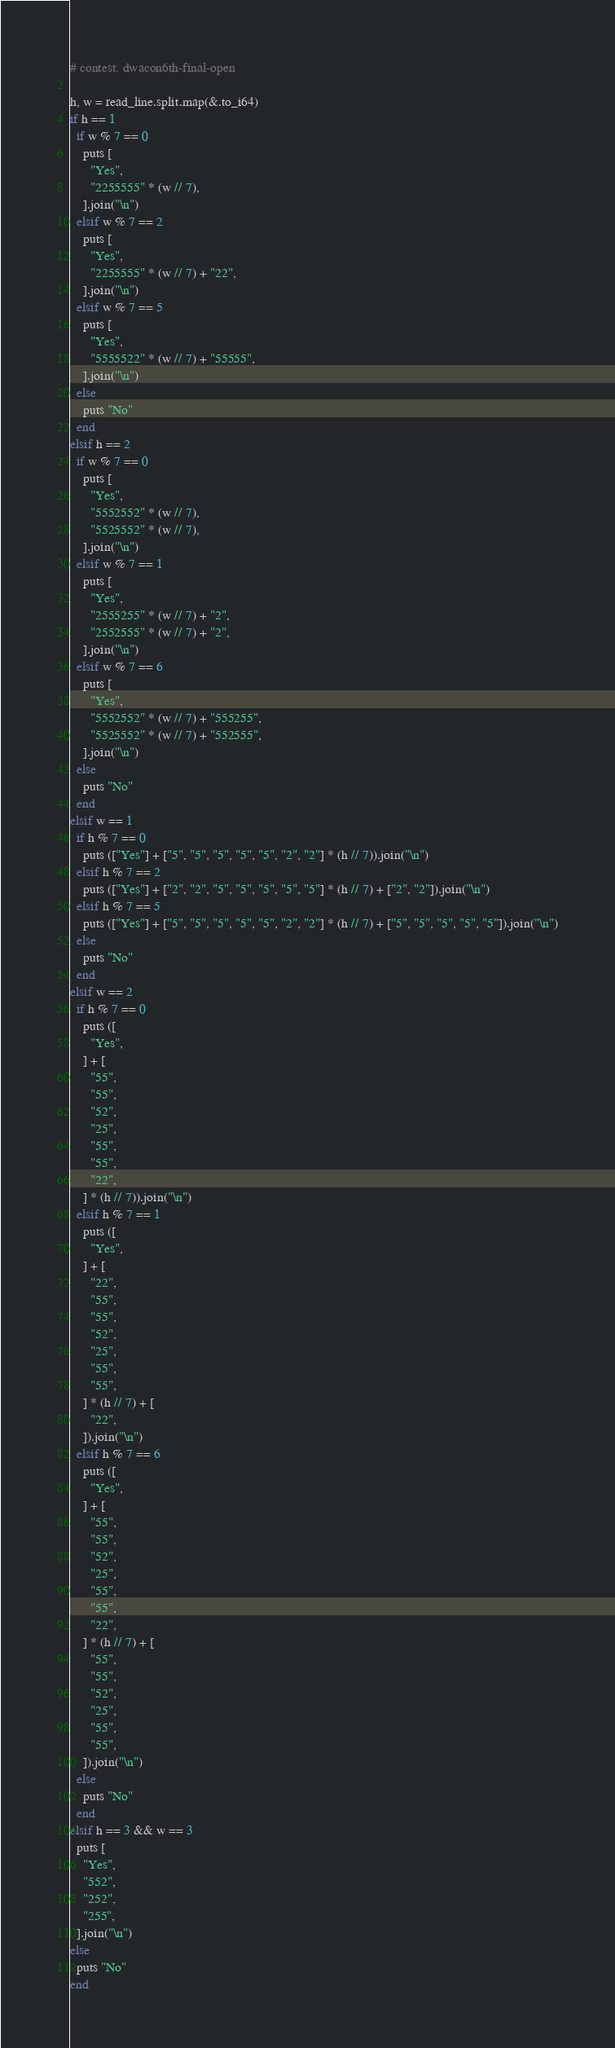<code> <loc_0><loc_0><loc_500><loc_500><_Crystal_># contest: dwacon6th-final-open

h, w = read_line.split.map(&.to_i64)
if h == 1
  if w % 7 == 0
    puts [
      "Yes",
      "2255555" * (w // 7),
    ].join("\n")
  elsif w % 7 == 2
    puts [
      "Yes",
      "2255555" * (w // 7) + "22",
    ].join("\n")
  elsif w % 7 == 5
    puts [
      "Yes",
      "5555522" * (w // 7) + "55555",
    ].join("\n")
  else
    puts "No"
  end
elsif h == 2
  if w % 7 == 0
    puts [
      "Yes",
      "5552552" * (w // 7),
      "5525552" * (w // 7),
    ].join("\n")
  elsif w % 7 == 1
    puts [
      "Yes",
      "2555255" * (w // 7) + "2",
      "2552555" * (w // 7) + "2",
    ].join("\n")
  elsif w % 7 == 6
    puts [
      "Yes",
      "5552552" * (w // 7) + "555255",
      "5525552" * (w // 7) + "552555",
    ].join("\n")
  else
    puts "No"
  end
elsif w == 1
  if h % 7 == 0
    puts (["Yes"] + ["5", "5", "5", "5", "5", "2", "2"] * (h // 7)).join("\n")
  elsif h % 7 == 2
    puts (["Yes"] + ["2", "2", "5", "5", "5", "5", "5"] * (h // 7) + ["2", "2"]).join("\n")
  elsif h % 7 == 5
    puts (["Yes"] + ["5", "5", "5", "5", "5", "2", "2"] * (h // 7) + ["5", "5", "5", "5", "5"]).join("\n")
  else
    puts "No"
  end
elsif w == 2
  if h % 7 == 0
    puts ([
      "Yes",
    ] + [
      "55",
      "55",
      "52",
      "25",
      "55",
      "55",
      "22",
    ] * (h // 7)).join("\n")
  elsif h % 7 == 1
    puts ([
      "Yes",
    ] + [
      "22",
      "55",
      "55",
      "52",
      "25",
      "55",
      "55",
    ] * (h // 7) + [
      "22",
    ]).join("\n")
  elsif h % 7 == 6
    puts ([
      "Yes",
    ] + [
      "55",
      "55",
      "52",
      "25",
      "55",
      "55",
      "22",
    ] * (h // 7) + [
      "55",
      "55",
      "52",
      "25",
      "55",
      "55",
    ]).join("\n")
  else
    puts "No"
  end
elsif h == 3 && w == 3
  puts [
    "Yes",
    "552",
    "252",
    "255",
  ].join("\n")
else
  puts "No"
end
</code> 